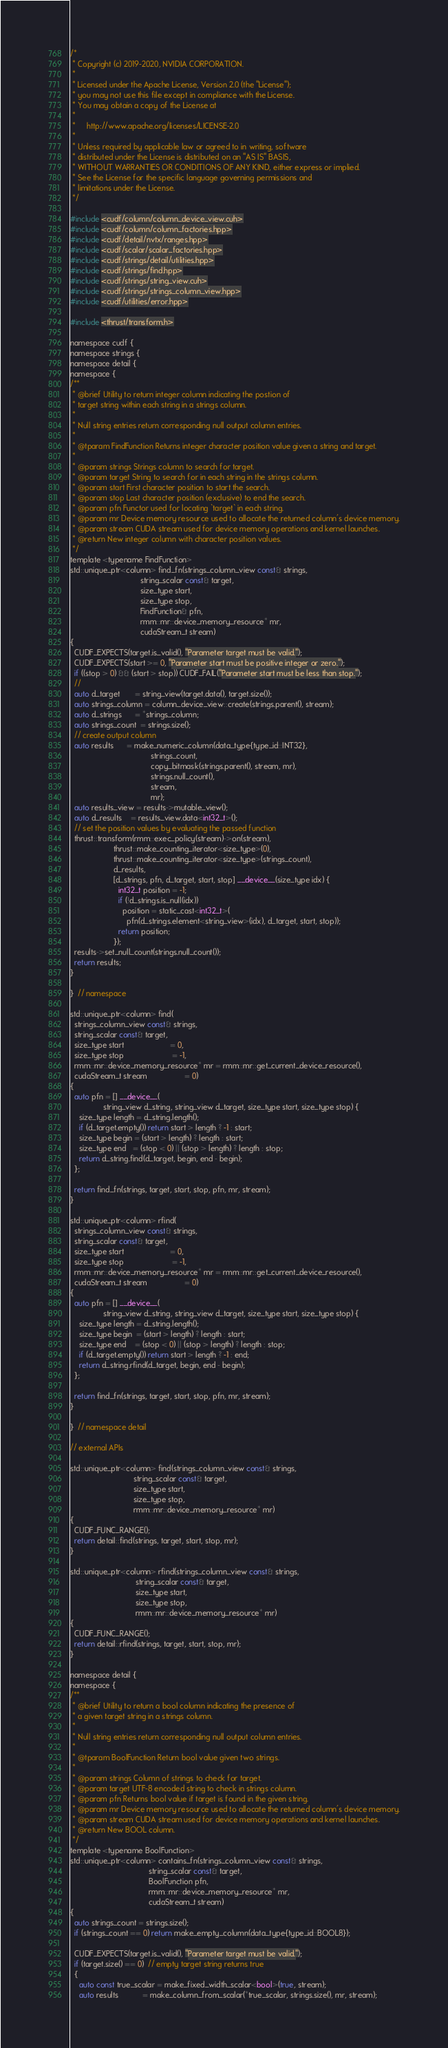<code> <loc_0><loc_0><loc_500><loc_500><_Cuda_>/*
 * Copyright (c) 2019-2020, NVIDIA CORPORATION.
 *
 * Licensed under the Apache License, Version 2.0 (the "License");
 * you may not use this file except in compliance with the License.
 * You may obtain a copy of the License at
 *
 *     http://www.apache.org/licenses/LICENSE-2.0
 *
 * Unless required by applicable law or agreed to in writing, software
 * distributed under the License is distributed on an "AS IS" BASIS,
 * WITHOUT WARRANTIES OR CONDITIONS OF ANY KIND, either express or implied.
 * See the License for the specific language governing permissions and
 * limitations under the License.
 */

#include <cudf/column/column_device_view.cuh>
#include <cudf/column/column_factories.hpp>
#include <cudf/detail/nvtx/ranges.hpp>
#include <cudf/scalar/scalar_factories.hpp>
#include <cudf/strings/detail/utilities.hpp>
#include <cudf/strings/find.hpp>
#include <cudf/strings/string_view.cuh>
#include <cudf/strings/strings_column_view.hpp>
#include <cudf/utilities/error.hpp>

#include <thrust/transform.h>

namespace cudf {
namespace strings {
namespace detail {
namespace {
/**
 * @brief Utility to return integer column indicating the postion of
 * target string within each string in a strings column.
 *
 * Null string entries return corresponding null output column entries.
 *
 * @tparam FindFunction Returns integer character position value given a string and target.
 *
 * @param strings Strings column to search for target.
 * @param target String to search for in each string in the strings column.
 * @param start First character position to start the search.
 * @param stop Last character position (exclusive) to end the search.
 * @param pfn Functor used for locating `target` in each string.
 * @param mr Device memory resource used to allocate the returned column's device memory.
 * @param stream CUDA stream used for device memory operations and kernel launches.
 * @return New integer column with character position values.
 */
template <typename FindFunction>
std::unique_ptr<column> find_fn(strings_column_view const& strings,
                                string_scalar const& target,
                                size_type start,
                                size_type stop,
                                FindFunction& pfn,
                                rmm::mr::device_memory_resource* mr,
                                cudaStream_t stream)
{
  CUDF_EXPECTS(target.is_valid(), "Parameter target must be valid.");
  CUDF_EXPECTS(start >= 0, "Parameter start must be positive integer or zero.");
  if ((stop > 0) && (start > stop)) CUDF_FAIL("Parameter start must be less than stop.");
  //
  auto d_target       = string_view(target.data(), target.size());
  auto strings_column = column_device_view::create(strings.parent(), stream);
  auto d_strings      = *strings_column;
  auto strings_count  = strings.size();
  // create output column
  auto results      = make_numeric_column(data_type{type_id::INT32},
                                     strings_count,
                                     copy_bitmask(strings.parent(), stream, mr),
                                     strings.null_count(),
                                     stream,
                                     mr);
  auto results_view = results->mutable_view();
  auto d_results    = results_view.data<int32_t>();
  // set the position values by evaluating the passed function
  thrust::transform(rmm::exec_policy(stream)->on(stream),
                    thrust::make_counting_iterator<size_type>(0),
                    thrust::make_counting_iterator<size_type>(strings_count),
                    d_results,
                    [d_strings, pfn, d_target, start, stop] __device__(size_type idx) {
                      int32_t position = -1;
                      if (!d_strings.is_null(idx))
                        position = static_cast<int32_t>(
                          pfn(d_strings.element<string_view>(idx), d_target, start, stop));
                      return position;
                    });
  results->set_null_count(strings.null_count());
  return results;
}

}  // namespace

std::unique_ptr<column> find(
  strings_column_view const& strings,
  string_scalar const& target,
  size_type start                     = 0,
  size_type stop                      = -1,
  rmm::mr::device_memory_resource* mr = rmm::mr::get_current_device_resource(),
  cudaStream_t stream                 = 0)
{
  auto pfn = [] __device__(
               string_view d_string, string_view d_target, size_type start, size_type stop) {
    size_type length = d_string.length();
    if (d_target.empty()) return start > length ? -1 : start;
    size_type begin = (start > length) ? length : start;
    size_type end   = (stop < 0) || (stop > length) ? length : stop;
    return d_string.find(d_target, begin, end - begin);
  };

  return find_fn(strings, target, start, stop, pfn, mr, stream);
}

std::unique_ptr<column> rfind(
  strings_column_view const& strings,
  string_scalar const& target,
  size_type start                     = 0,
  size_type stop                      = -1,
  rmm::mr::device_memory_resource* mr = rmm::mr::get_current_device_resource(),
  cudaStream_t stream                 = 0)
{
  auto pfn = [] __device__(
               string_view d_string, string_view d_target, size_type start, size_type stop) {
    size_type length = d_string.length();
    size_type begin  = (start > length) ? length : start;
    size_type end    = (stop < 0) || (stop > length) ? length : stop;
    if (d_target.empty()) return start > length ? -1 : end;
    return d_string.rfind(d_target, begin, end - begin);
  };

  return find_fn(strings, target, start, stop, pfn, mr, stream);
}

}  // namespace detail

// external APIs

std::unique_ptr<column> find(strings_column_view const& strings,
                             string_scalar const& target,
                             size_type start,
                             size_type stop,
                             rmm::mr::device_memory_resource* mr)
{
  CUDF_FUNC_RANGE();
  return detail::find(strings, target, start, stop, mr);
}

std::unique_ptr<column> rfind(strings_column_view const& strings,
                              string_scalar const& target,
                              size_type start,
                              size_type stop,
                              rmm::mr::device_memory_resource* mr)
{
  CUDF_FUNC_RANGE();
  return detail::rfind(strings, target, start, stop, mr);
}

namespace detail {
namespace {
/**
 * @brief Utility to return a bool column indicating the presence of
 * a given target string in a strings column.
 *
 * Null string entries return corresponding null output column entries.
 *
 * @tparam BoolFunction Return bool value given two strings.
 *
 * @param strings Column of strings to check for target.
 * @param target UTF-8 encoded string to check in strings column.
 * @param pfn Returns bool value if target is found in the given string.
 * @param mr Device memory resource used to allocate the returned column's device memory.
 * @param stream CUDA stream used for device memory operations and kernel launches.
 * @return New BOOL column.
 */
template <typename BoolFunction>
std::unique_ptr<column> contains_fn(strings_column_view const& strings,
                                    string_scalar const& target,
                                    BoolFunction pfn,
                                    rmm::mr::device_memory_resource* mr,
                                    cudaStream_t stream)
{
  auto strings_count = strings.size();
  if (strings_count == 0) return make_empty_column(data_type{type_id::BOOL8});

  CUDF_EXPECTS(target.is_valid(), "Parameter target must be valid.");
  if (target.size() == 0)  // empty target string returns true
  {
    auto const true_scalar = make_fixed_width_scalar<bool>(true, stream);
    auto results           = make_column_from_scalar(*true_scalar, strings.size(), mr, stream);</code> 